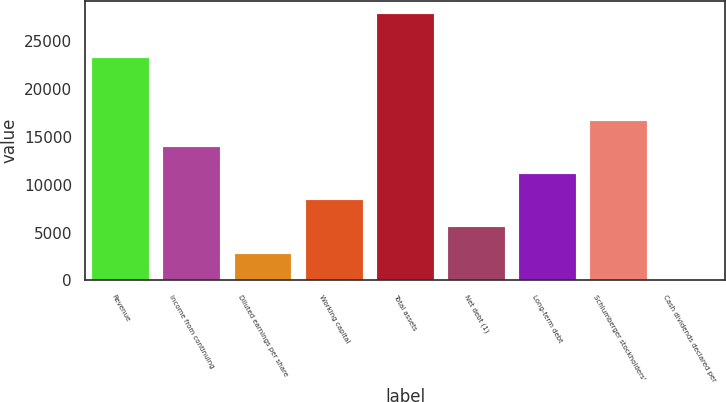Convert chart. <chart><loc_0><loc_0><loc_500><loc_500><bar_chart><fcel>Revenue<fcel>Income from continuing<fcel>Diluted earnings per share<fcel>Working capital<fcel>Total assets<fcel>Net debt (1)<fcel>Long-term debt<fcel>Schlumberger stockholders'<fcel>Cash dividends declared per<nl><fcel>23277<fcel>13926.9<fcel>2785.93<fcel>8356.39<fcel>27853<fcel>5571.16<fcel>11141.6<fcel>16712.1<fcel>0.7<nl></chart> 